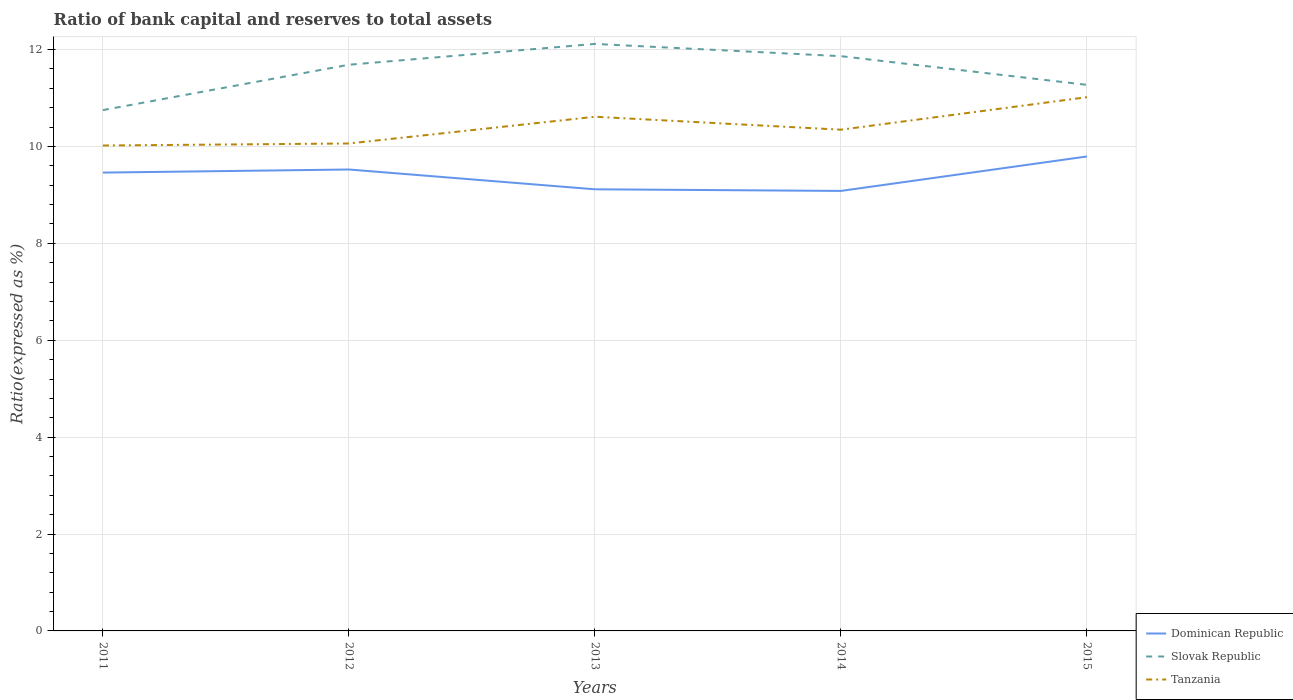Does the line corresponding to Slovak Republic intersect with the line corresponding to Tanzania?
Give a very brief answer. No. Across all years, what is the maximum ratio of bank capital and reserves to total assets in Slovak Republic?
Provide a short and direct response. 10.75. In which year was the ratio of bank capital and reserves to total assets in Slovak Republic maximum?
Make the answer very short. 2011. What is the total ratio of bank capital and reserves to total assets in Tanzania in the graph?
Offer a very short reply. -0.67. What is the difference between the highest and the second highest ratio of bank capital and reserves to total assets in Dominican Republic?
Your answer should be very brief. 0.71. What is the difference between the highest and the lowest ratio of bank capital and reserves to total assets in Slovak Republic?
Your answer should be compact. 3. Is the ratio of bank capital and reserves to total assets in Slovak Republic strictly greater than the ratio of bank capital and reserves to total assets in Tanzania over the years?
Offer a terse response. No. How many lines are there?
Provide a short and direct response. 3. How many years are there in the graph?
Make the answer very short. 5. Are the values on the major ticks of Y-axis written in scientific E-notation?
Offer a very short reply. No. Does the graph contain any zero values?
Keep it short and to the point. No. Does the graph contain grids?
Provide a succinct answer. Yes. How many legend labels are there?
Keep it short and to the point. 3. What is the title of the graph?
Offer a terse response. Ratio of bank capital and reserves to total assets. Does "Cameroon" appear as one of the legend labels in the graph?
Offer a terse response. No. What is the label or title of the X-axis?
Offer a terse response. Years. What is the label or title of the Y-axis?
Make the answer very short. Ratio(expressed as %). What is the Ratio(expressed as %) of Dominican Republic in 2011?
Make the answer very short. 9.46. What is the Ratio(expressed as %) in Slovak Republic in 2011?
Provide a short and direct response. 10.75. What is the Ratio(expressed as %) of Tanzania in 2011?
Ensure brevity in your answer.  10.02. What is the Ratio(expressed as %) of Dominican Republic in 2012?
Give a very brief answer. 9.52. What is the Ratio(expressed as %) of Slovak Republic in 2012?
Provide a short and direct response. 11.69. What is the Ratio(expressed as %) of Tanzania in 2012?
Your answer should be very brief. 10.06. What is the Ratio(expressed as %) in Dominican Republic in 2013?
Give a very brief answer. 9.12. What is the Ratio(expressed as %) in Slovak Republic in 2013?
Keep it short and to the point. 12.12. What is the Ratio(expressed as %) of Tanzania in 2013?
Provide a short and direct response. 10.61. What is the Ratio(expressed as %) in Dominican Republic in 2014?
Your answer should be very brief. 9.08. What is the Ratio(expressed as %) of Slovak Republic in 2014?
Your answer should be compact. 11.86. What is the Ratio(expressed as %) of Tanzania in 2014?
Ensure brevity in your answer.  10.35. What is the Ratio(expressed as %) in Dominican Republic in 2015?
Your answer should be very brief. 9.79. What is the Ratio(expressed as %) in Slovak Republic in 2015?
Give a very brief answer. 11.27. What is the Ratio(expressed as %) of Tanzania in 2015?
Your response must be concise. 11.02. Across all years, what is the maximum Ratio(expressed as %) of Dominican Republic?
Ensure brevity in your answer.  9.79. Across all years, what is the maximum Ratio(expressed as %) of Slovak Republic?
Your response must be concise. 12.12. Across all years, what is the maximum Ratio(expressed as %) of Tanzania?
Your answer should be compact. 11.02. Across all years, what is the minimum Ratio(expressed as %) of Dominican Republic?
Your answer should be compact. 9.08. Across all years, what is the minimum Ratio(expressed as %) in Slovak Republic?
Provide a short and direct response. 10.75. Across all years, what is the minimum Ratio(expressed as %) of Tanzania?
Ensure brevity in your answer.  10.02. What is the total Ratio(expressed as %) in Dominican Republic in the graph?
Offer a terse response. 46.98. What is the total Ratio(expressed as %) of Slovak Republic in the graph?
Keep it short and to the point. 57.69. What is the total Ratio(expressed as %) of Tanzania in the graph?
Ensure brevity in your answer.  52.06. What is the difference between the Ratio(expressed as %) in Dominican Republic in 2011 and that in 2012?
Your answer should be compact. -0.06. What is the difference between the Ratio(expressed as %) in Slovak Republic in 2011 and that in 2012?
Your answer should be compact. -0.94. What is the difference between the Ratio(expressed as %) in Tanzania in 2011 and that in 2012?
Provide a short and direct response. -0.04. What is the difference between the Ratio(expressed as %) in Dominican Republic in 2011 and that in 2013?
Your answer should be compact. 0.34. What is the difference between the Ratio(expressed as %) in Slovak Republic in 2011 and that in 2013?
Provide a short and direct response. -1.37. What is the difference between the Ratio(expressed as %) of Tanzania in 2011 and that in 2013?
Offer a terse response. -0.59. What is the difference between the Ratio(expressed as %) in Dominican Republic in 2011 and that in 2014?
Your answer should be compact. 0.38. What is the difference between the Ratio(expressed as %) of Slovak Republic in 2011 and that in 2014?
Your answer should be very brief. -1.11. What is the difference between the Ratio(expressed as %) of Tanzania in 2011 and that in 2014?
Make the answer very short. -0.33. What is the difference between the Ratio(expressed as %) of Dominican Republic in 2011 and that in 2015?
Give a very brief answer. -0.33. What is the difference between the Ratio(expressed as %) in Slovak Republic in 2011 and that in 2015?
Give a very brief answer. -0.52. What is the difference between the Ratio(expressed as %) in Tanzania in 2011 and that in 2015?
Give a very brief answer. -1. What is the difference between the Ratio(expressed as %) in Dominican Republic in 2012 and that in 2013?
Keep it short and to the point. 0.41. What is the difference between the Ratio(expressed as %) of Slovak Republic in 2012 and that in 2013?
Your answer should be compact. -0.43. What is the difference between the Ratio(expressed as %) of Tanzania in 2012 and that in 2013?
Provide a succinct answer. -0.55. What is the difference between the Ratio(expressed as %) in Dominican Republic in 2012 and that in 2014?
Provide a succinct answer. 0.44. What is the difference between the Ratio(expressed as %) in Slovak Republic in 2012 and that in 2014?
Provide a succinct answer. -0.18. What is the difference between the Ratio(expressed as %) of Tanzania in 2012 and that in 2014?
Ensure brevity in your answer.  -0.28. What is the difference between the Ratio(expressed as %) in Dominican Republic in 2012 and that in 2015?
Ensure brevity in your answer.  -0.27. What is the difference between the Ratio(expressed as %) in Slovak Republic in 2012 and that in 2015?
Keep it short and to the point. 0.42. What is the difference between the Ratio(expressed as %) of Tanzania in 2012 and that in 2015?
Offer a terse response. -0.96. What is the difference between the Ratio(expressed as %) in Slovak Republic in 2013 and that in 2014?
Ensure brevity in your answer.  0.25. What is the difference between the Ratio(expressed as %) of Tanzania in 2013 and that in 2014?
Provide a short and direct response. 0.27. What is the difference between the Ratio(expressed as %) of Dominican Republic in 2013 and that in 2015?
Offer a very short reply. -0.68. What is the difference between the Ratio(expressed as %) in Slovak Republic in 2013 and that in 2015?
Offer a very short reply. 0.84. What is the difference between the Ratio(expressed as %) in Tanzania in 2013 and that in 2015?
Your answer should be very brief. -0.4. What is the difference between the Ratio(expressed as %) in Dominican Republic in 2014 and that in 2015?
Provide a short and direct response. -0.71. What is the difference between the Ratio(expressed as %) in Slovak Republic in 2014 and that in 2015?
Make the answer very short. 0.59. What is the difference between the Ratio(expressed as %) in Tanzania in 2014 and that in 2015?
Your answer should be very brief. -0.67. What is the difference between the Ratio(expressed as %) in Dominican Republic in 2011 and the Ratio(expressed as %) in Slovak Republic in 2012?
Provide a succinct answer. -2.23. What is the difference between the Ratio(expressed as %) of Dominican Republic in 2011 and the Ratio(expressed as %) of Tanzania in 2012?
Provide a succinct answer. -0.6. What is the difference between the Ratio(expressed as %) in Slovak Republic in 2011 and the Ratio(expressed as %) in Tanzania in 2012?
Keep it short and to the point. 0.69. What is the difference between the Ratio(expressed as %) of Dominican Republic in 2011 and the Ratio(expressed as %) of Slovak Republic in 2013?
Keep it short and to the point. -2.66. What is the difference between the Ratio(expressed as %) of Dominican Republic in 2011 and the Ratio(expressed as %) of Tanzania in 2013?
Ensure brevity in your answer.  -1.15. What is the difference between the Ratio(expressed as %) of Slovak Republic in 2011 and the Ratio(expressed as %) of Tanzania in 2013?
Provide a succinct answer. 0.14. What is the difference between the Ratio(expressed as %) in Dominican Republic in 2011 and the Ratio(expressed as %) in Slovak Republic in 2014?
Give a very brief answer. -2.4. What is the difference between the Ratio(expressed as %) in Dominican Republic in 2011 and the Ratio(expressed as %) in Tanzania in 2014?
Make the answer very short. -0.89. What is the difference between the Ratio(expressed as %) of Slovak Republic in 2011 and the Ratio(expressed as %) of Tanzania in 2014?
Ensure brevity in your answer.  0.4. What is the difference between the Ratio(expressed as %) in Dominican Republic in 2011 and the Ratio(expressed as %) in Slovak Republic in 2015?
Your answer should be compact. -1.81. What is the difference between the Ratio(expressed as %) in Dominican Republic in 2011 and the Ratio(expressed as %) in Tanzania in 2015?
Offer a terse response. -1.56. What is the difference between the Ratio(expressed as %) in Slovak Republic in 2011 and the Ratio(expressed as %) in Tanzania in 2015?
Make the answer very short. -0.27. What is the difference between the Ratio(expressed as %) in Dominican Republic in 2012 and the Ratio(expressed as %) in Slovak Republic in 2013?
Ensure brevity in your answer.  -2.59. What is the difference between the Ratio(expressed as %) in Dominican Republic in 2012 and the Ratio(expressed as %) in Tanzania in 2013?
Keep it short and to the point. -1.09. What is the difference between the Ratio(expressed as %) of Slovak Republic in 2012 and the Ratio(expressed as %) of Tanzania in 2013?
Make the answer very short. 1.07. What is the difference between the Ratio(expressed as %) in Dominican Republic in 2012 and the Ratio(expressed as %) in Slovak Republic in 2014?
Offer a very short reply. -2.34. What is the difference between the Ratio(expressed as %) of Dominican Republic in 2012 and the Ratio(expressed as %) of Tanzania in 2014?
Offer a very short reply. -0.82. What is the difference between the Ratio(expressed as %) of Slovak Republic in 2012 and the Ratio(expressed as %) of Tanzania in 2014?
Your answer should be compact. 1.34. What is the difference between the Ratio(expressed as %) in Dominican Republic in 2012 and the Ratio(expressed as %) in Slovak Republic in 2015?
Ensure brevity in your answer.  -1.75. What is the difference between the Ratio(expressed as %) of Dominican Republic in 2012 and the Ratio(expressed as %) of Tanzania in 2015?
Your response must be concise. -1.49. What is the difference between the Ratio(expressed as %) in Slovak Republic in 2012 and the Ratio(expressed as %) in Tanzania in 2015?
Your answer should be very brief. 0.67. What is the difference between the Ratio(expressed as %) in Dominican Republic in 2013 and the Ratio(expressed as %) in Slovak Republic in 2014?
Your response must be concise. -2.75. What is the difference between the Ratio(expressed as %) of Dominican Republic in 2013 and the Ratio(expressed as %) of Tanzania in 2014?
Your answer should be very brief. -1.23. What is the difference between the Ratio(expressed as %) in Slovak Republic in 2013 and the Ratio(expressed as %) in Tanzania in 2014?
Make the answer very short. 1.77. What is the difference between the Ratio(expressed as %) in Dominican Republic in 2013 and the Ratio(expressed as %) in Slovak Republic in 2015?
Keep it short and to the point. -2.16. What is the difference between the Ratio(expressed as %) of Dominican Republic in 2013 and the Ratio(expressed as %) of Tanzania in 2015?
Your answer should be compact. -1.9. What is the difference between the Ratio(expressed as %) in Slovak Republic in 2013 and the Ratio(expressed as %) in Tanzania in 2015?
Provide a short and direct response. 1.1. What is the difference between the Ratio(expressed as %) of Dominican Republic in 2014 and the Ratio(expressed as %) of Slovak Republic in 2015?
Provide a short and direct response. -2.19. What is the difference between the Ratio(expressed as %) in Dominican Republic in 2014 and the Ratio(expressed as %) in Tanzania in 2015?
Provide a short and direct response. -1.93. What is the difference between the Ratio(expressed as %) of Slovak Republic in 2014 and the Ratio(expressed as %) of Tanzania in 2015?
Your answer should be very brief. 0.85. What is the average Ratio(expressed as %) in Dominican Republic per year?
Your answer should be compact. 9.4. What is the average Ratio(expressed as %) of Slovak Republic per year?
Ensure brevity in your answer.  11.54. What is the average Ratio(expressed as %) in Tanzania per year?
Your response must be concise. 10.41. In the year 2011, what is the difference between the Ratio(expressed as %) of Dominican Republic and Ratio(expressed as %) of Slovak Republic?
Your answer should be compact. -1.29. In the year 2011, what is the difference between the Ratio(expressed as %) of Dominican Republic and Ratio(expressed as %) of Tanzania?
Your answer should be compact. -0.56. In the year 2011, what is the difference between the Ratio(expressed as %) in Slovak Republic and Ratio(expressed as %) in Tanzania?
Provide a short and direct response. 0.73. In the year 2012, what is the difference between the Ratio(expressed as %) in Dominican Republic and Ratio(expressed as %) in Slovak Republic?
Provide a succinct answer. -2.16. In the year 2012, what is the difference between the Ratio(expressed as %) in Dominican Republic and Ratio(expressed as %) in Tanzania?
Offer a very short reply. -0.54. In the year 2012, what is the difference between the Ratio(expressed as %) in Slovak Republic and Ratio(expressed as %) in Tanzania?
Provide a succinct answer. 1.63. In the year 2013, what is the difference between the Ratio(expressed as %) of Dominican Republic and Ratio(expressed as %) of Slovak Republic?
Give a very brief answer. -3. In the year 2013, what is the difference between the Ratio(expressed as %) in Dominican Republic and Ratio(expressed as %) in Tanzania?
Give a very brief answer. -1.5. In the year 2013, what is the difference between the Ratio(expressed as %) in Slovak Republic and Ratio(expressed as %) in Tanzania?
Provide a short and direct response. 1.5. In the year 2014, what is the difference between the Ratio(expressed as %) of Dominican Republic and Ratio(expressed as %) of Slovak Republic?
Your answer should be compact. -2.78. In the year 2014, what is the difference between the Ratio(expressed as %) in Dominican Republic and Ratio(expressed as %) in Tanzania?
Give a very brief answer. -1.26. In the year 2014, what is the difference between the Ratio(expressed as %) of Slovak Republic and Ratio(expressed as %) of Tanzania?
Your answer should be compact. 1.52. In the year 2015, what is the difference between the Ratio(expressed as %) in Dominican Republic and Ratio(expressed as %) in Slovak Republic?
Provide a short and direct response. -1.48. In the year 2015, what is the difference between the Ratio(expressed as %) of Dominican Republic and Ratio(expressed as %) of Tanzania?
Ensure brevity in your answer.  -1.22. In the year 2015, what is the difference between the Ratio(expressed as %) in Slovak Republic and Ratio(expressed as %) in Tanzania?
Give a very brief answer. 0.25. What is the ratio of the Ratio(expressed as %) of Dominican Republic in 2011 to that in 2012?
Make the answer very short. 0.99. What is the ratio of the Ratio(expressed as %) of Slovak Republic in 2011 to that in 2012?
Ensure brevity in your answer.  0.92. What is the ratio of the Ratio(expressed as %) of Tanzania in 2011 to that in 2012?
Give a very brief answer. 1. What is the ratio of the Ratio(expressed as %) of Dominican Republic in 2011 to that in 2013?
Keep it short and to the point. 1.04. What is the ratio of the Ratio(expressed as %) in Slovak Republic in 2011 to that in 2013?
Give a very brief answer. 0.89. What is the ratio of the Ratio(expressed as %) of Tanzania in 2011 to that in 2013?
Provide a short and direct response. 0.94. What is the ratio of the Ratio(expressed as %) in Dominican Republic in 2011 to that in 2014?
Your answer should be very brief. 1.04. What is the ratio of the Ratio(expressed as %) in Slovak Republic in 2011 to that in 2014?
Provide a succinct answer. 0.91. What is the ratio of the Ratio(expressed as %) of Tanzania in 2011 to that in 2014?
Offer a very short reply. 0.97. What is the ratio of the Ratio(expressed as %) of Dominican Republic in 2011 to that in 2015?
Offer a terse response. 0.97. What is the ratio of the Ratio(expressed as %) in Slovak Republic in 2011 to that in 2015?
Provide a short and direct response. 0.95. What is the ratio of the Ratio(expressed as %) of Tanzania in 2011 to that in 2015?
Your response must be concise. 0.91. What is the ratio of the Ratio(expressed as %) of Dominican Republic in 2012 to that in 2013?
Keep it short and to the point. 1.04. What is the ratio of the Ratio(expressed as %) of Slovak Republic in 2012 to that in 2013?
Ensure brevity in your answer.  0.96. What is the ratio of the Ratio(expressed as %) in Tanzania in 2012 to that in 2013?
Make the answer very short. 0.95. What is the ratio of the Ratio(expressed as %) of Dominican Republic in 2012 to that in 2014?
Provide a succinct answer. 1.05. What is the ratio of the Ratio(expressed as %) in Slovak Republic in 2012 to that in 2014?
Your response must be concise. 0.99. What is the ratio of the Ratio(expressed as %) in Tanzania in 2012 to that in 2014?
Keep it short and to the point. 0.97. What is the ratio of the Ratio(expressed as %) of Dominican Republic in 2012 to that in 2015?
Provide a succinct answer. 0.97. What is the ratio of the Ratio(expressed as %) in Slovak Republic in 2012 to that in 2015?
Your answer should be very brief. 1.04. What is the ratio of the Ratio(expressed as %) of Tanzania in 2012 to that in 2015?
Ensure brevity in your answer.  0.91. What is the ratio of the Ratio(expressed as %) in Dominican Republic in 2013 to that in 2014?
Your response must be concise. 1. What is the ratio of the Ratio(expressed as %) of Slovak Republic in 2013 to that in 2014?
Your answer should be very brief. 1.02. What is the ratio of the Ratio(expressed as %) in Tanzania in 2013 to that in 2014?
Your response must be concise. 1.03. What is the ratio of the Ratio(expressed as %) of Dominican Republic in 2013 to that in 2015?
Keep it short and to the point. 0.93. What is the ratio of the Ratio(expressed as %) in Slovak Republic in 2013 to that in 2015?
Ensure brevity in your answer.  1.07. What is the ratio of the Ratio(expressed as %) of Tanzania in 2013 to that in 2015?
Your answer should be very brief. 0.96. What is the ratio of the Ratio(expressed as %) in Dominican Republic in 2014 to that in 2015?
Your answer should be compact. 0.93. What is the ratio of the Ratio(expressed as %) of Slovak Republic in 2014 to that in 2015?
Your answer should be compact. 1.05. What is the ratio of the Ratio(expressed as %) of Tanzania in 2014 to that in 2015?
Ensure brevity in your answer.  0.94. What is the difference between the highest and the second highest Ratio(expressed as %) in Dominican Republic?
Your response must be concise. 0.27. What is the difference between the highest and the second highest Ratio(expressed as %) in Slovak Republic?
Offer a very short reply. 0.25. What is the difference between the highest and the second highest Ratio(expressed as %) in Tanzania?
Provide a short and direct response. 0.4. What is the difference between the highest and the lowest Ratio(expressed as %) in Dominican Republic?
Your answer should be compact. 0.71. What is the difference between the highest and the lowest Ratio(expressed as %) in Slovak Republic?
Provide a short and direct response. 1.37. 